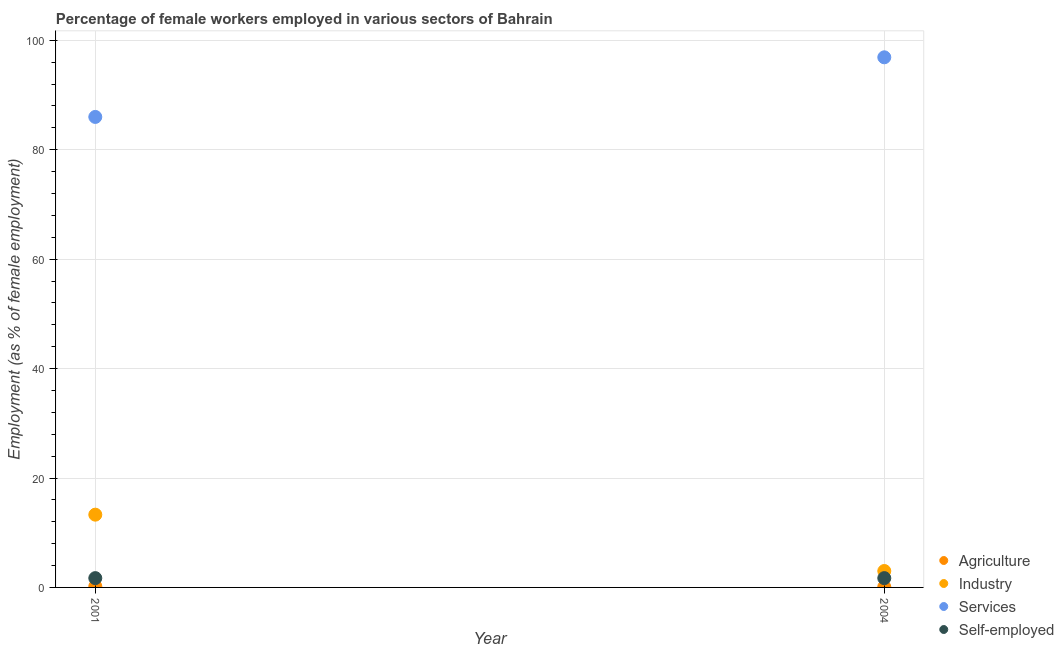Is the number of dotlines equal to the number of legend labels?
Offer a very short reply. Yes. What is the percentage of female workers in industry in 2001?
Provide a succinct answer. 13.3. Across all years, what is the maximum percentage of female workers in industry?
Provide a succinct answer. 13.3. Across all years, what is the minimum percentage of self employed female workers?
Provide a succinct answer. 1.7. What is the total percentage of female workers in industry in the graph?
Offer a very short reply. 16.3. What is the difference between the percentage of female workers in services in 2001 and the percentage of self employed female workers in 2004?
Make the answer very short. 84.3. What is the average percentage of female workers in agriculture per year?
Your response must be concise. 0.15. In the year 2001, what is the difference between the percentage of female workers in agriculture and percentage of female workers in industry?
Your answer should be compact. -13.1. What is the ratio of the percentage of female workers in services in 2001 to that in 2004?
Your answer should be compact. 0.89. Is the percentage of female workers in agriculture in 2001 less than that in 2004?
Provide a short and direct response. No. In how many years, is the percentage of self employed female workers greater than the average percentage of self employed female workers taken over all years?
Offer a very short reply. 0. Is it the case that in every year, the sum of the percentage of female workers in industry and percentage of female workers in services is greater than the sum of percentage of female workers in agriculture and percentage of self employed female workers?
Offer a very short reply. Yes. Is it the case that in every year, the sum of the percentage of female workers in agriculture and percentage of female workers in industry is greater than the percentage of female workers in services?
Give a very brief answer. No. Is the percentage of female workers in industry strictly less than the percentage of self employed female workers over the years?
Make the answer very short. No. How many years are there in the graph?
Your answer should be compact. 2. Are the values on the major ticks of Y-axis written in scientific E-notation?
Offer a very short reply. No. Does the graph contain grids?
Ensure brevity in your answer.  Yes. Where does the legend appear in the graph?
Keep it short and to the point. Bottom right. How many legend labels are there?
Give a very brief answer. 4. How are the legend labels stacked?
Your answer should be compact. Vertical. What is the title of the graph?
Provide a short and direct response. Percentage of female workers employed in various sectors of Bahrain. What is the label or title of the Y-axis?
Provide a succinct answer. Employment (as % of female employment). What is the Employment (as % of female employment) of Agriculture in 2001?
Offer a very short reply. 0.2. What is the Employment (as % of female employment) of Industry in 2001?
Your answer should be compact. 13.3. What is the Employment (as % of female employment) in Services in 2001?
Your answer should be compact. 86. What is the Employment (as % of female employment) of Self-employed in 2001?
Ensure brevity in your answer.  1.7. What is the Employment (as % of female employment) of Agriculture in 2004?
Offer a very short reply. 0.1. What is the Employment (as % of female employment) in Industry in 2004?
Offer a terse response. 3. What is the Employment (as % of female employment) in Services in 2004?
Keep it short and to the point. 96.9. What is the Employment (as % of female employment) of Self-employed in 2004?
Your response must be concise. 1.7. Across all years, what is the maximum Employment (as % of female employment) of Agriculture?
Provide a short and direct response. 0.2. Across all years, what is the maximum Employment (as % of female employment) of Industry?
Make the answer very short. 13.3. Across all years, what is the maximum Employment (as % of female employment) of Services?
Your response must be concise. 96.9. Across all years, what is the maximum Employment (as % of female employment) of Self-employed?
Offer a very short reply. 1.7. Across all years, what is the minimum Employment (as % of female employment) of Agriculture?
Provide a succinct answer. 0.1. Across all years, what is the minimum Employment (as % of female employment) in Industry?
Your response must be concise. 3. Across all years, what is the minimum Employment (as % of female employment) in Self-employed?
Make the answer very short. 1.7. What is the total Employment (as % of female employment) in Agriculture in the graph?
Offer a terse response. 0.3. What is the total Employment (as % of female employment) in Services in the graph?
Your response must be concise. 182.9. What is the total Employment (as % of female employment) of Self-employed in the graph?
Your answer should be compact. 3.4. What is the difference between the Employment (as % of female employment) in Agriculture in 2001 and that in 2004?
Your response must be concise. 0.1. What is the difference between the Employment (as % of female employment) of Services in 2001 and that in 2004?
Keep it short and to the point. -10.9. What is the difference between the Employment (as % of female employment) in Agriculture in 2001 and the Employment (as % of female employment) in Industry in 2004?
Keep it short and to the point. -2.8. What is the difference between the Employment (as % of female employment) in Agriculture in 2001 and the Employment (as % of female employment) in Services in 2004?
Provide a short and direct response. -96.7. What is the difference between the Employment (as % of female employment) of Industry in 2001 and the Employment (as % of female employment) of Services in 2004?
Your answer should be compact. -83.6. What is the difference between the Employment (as % of female employment) in Industry in 2001 and the Employment (as % of female employment) in Self-employed in 2004?
Offer a very short reply. 11.6. What is the difference between the Employment (as % of female employment) of Services in 2001 and the Employment (as % of female employment) of Self-employed in 2004?
Your answer should be very brief. 84.3. What is the average Employment (as % of female employment) in Industry per year?
Provide a succinct answer. 8.15. What is the average Employment (as % of female employment) in Services per year?
Offer a very short reply. 91.45. In the year 2001, what is the difference between the Employment (as % of female employment) in Agriculture and Employment (as % of female employment) in Services?
Your answer should be very brief. -85.8. In the year 2001, what is the difference between the Employment (as % of female employment) of Industry and Employment (as % of female employment) of Services?
Ensure brevity in your answer.  -72.7. In the year 2001, what is the difference between the Employment (as % of female employment) in Services and Employment (as % of female employment) in Self-employed?
Your answer should be very brief. 84.3. In the year 2004, what is the difference between the Employment (as % of female employment) in Agriculture and Employment (as % of female employment) in Services?
Ensure brevity in your answer.  -96.8. In the year 2004, what is the difference between the Employment (as % of female employment) in Agriculture and Employment (as % of female employment) in Self-employed?
Offer a very short reply. -1.6. In the year 2004, what is the difference between the Employment (as % of female employment) of Industry and Employment (as % of female employment) of Services?
Offer a terse response. -93.9. In the year 2004, what is the difference between the Employment (as % of female employment) of Services and Employment (as % of female employment) of Self-employed?
Make the answer very short. 95.2. What is the ratio of the Employment (as % of female employment) in Industry in 2001 to that in 2004?
Give a very brief answer. 4.43. What is the ratio of the Employment (as % of female employment) of Services in 2001 to that in 2004?
Offer a terse response. 0.89. What is the difference between the highest and the second highest Employment (as % of female employment) in Industry?
Keep it short and to the point. 10.3. What is the difference between the highest and the second highest Employment (as % of female employment) in Self-employed?
Offer a very short reply. 0. 